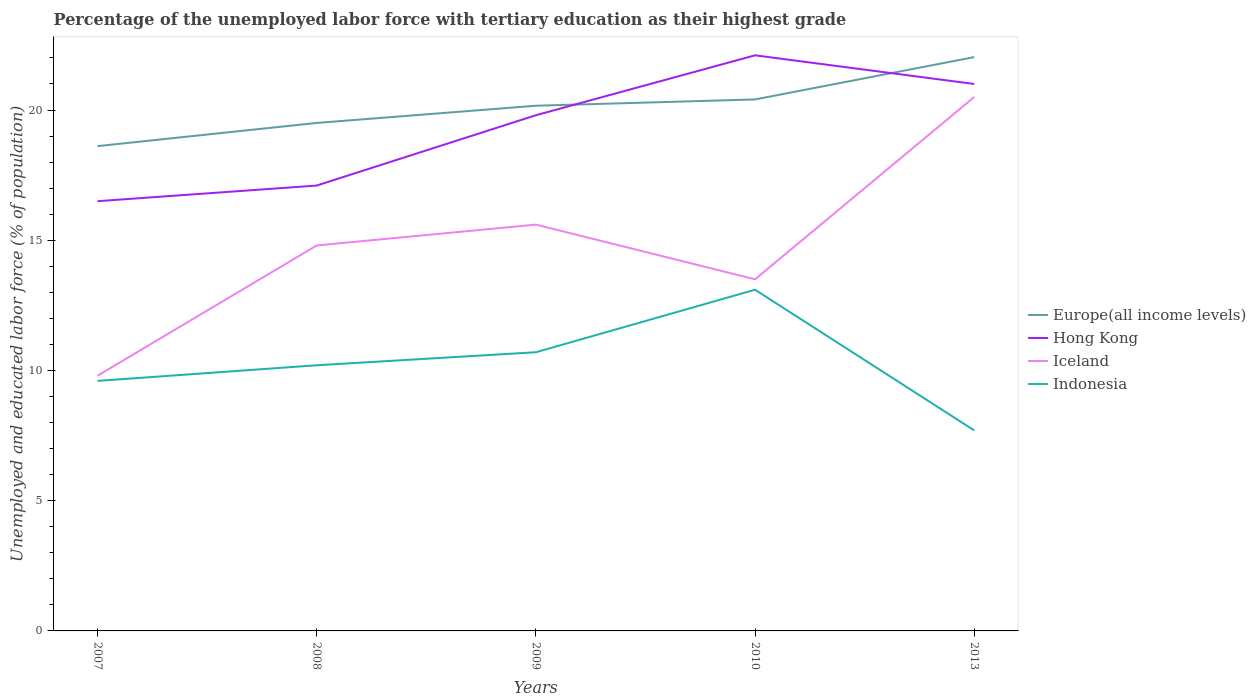How many different coloured lines are there?
Make the answer very short. 4. Does the line corresponding to Hong Kong intersect with the line corresponding to Indonesia?
Your answer should be very brief. No. Across all years, what is the maximum percentage of the unemployed labor force with tertiary education in Iceland?
Your response must be concise. 9.8. What is the total percentage of the unemployed labor force with tertiary education in Iceland in the graph?
Keep it short and to the point. -0.8. What is the difference between the highest and the second highest percentage of the unemployed labor force with tertiary education in Europe(all income levels)?
Make the answer very short. 3.42. What is the difference between the highest and the lowest percentage of the unemployed labor force with tertiary education in Indonesia?
Offer a very short reply. 2. Are the values on the major ticks of Y-axis written in scientific E-notation?
Give a very brief answer. No. Does the graph contain any zero values?
Give a very brief answer. No. Does the graph contain grids?
Provide a succinct answer. No. How many legend labels are there?
Make the answer very short. 4. How are the legend labels stacked?
Offer a terse response. Vertical. What is the title of the graph?
Keep it short and to the point. Percentage of the unemployed labor force with tertiary education as their highest grade. Does "Kyrgyz Republic" appear as one of the legend labels in the graph?
Ensure brevity in your answer.  No. What is the label or title of the Y-axis?
Provide a succinct answer. Unemployed and educated labor force (% of population). What is the Unemployed and educated labor force (% of population) of Europe(all income levels) in 2007?
Offer a terse response. 18.61. What is the Unemployed and educated labor force (% of population) of Iceland in 2007?
Make the answer very short. 9.8. What is the Unemployed and educated labor force (% of population) in Indonesia in 2007?
Provide a succinct answer. 9.6. What is the Unemployed and educated labor force (% of population) in Europe(all income levels) in 2008?
Make the answer very short. 19.5. What is the Unemployed and educated labor force (% of population) of Hong Kong in 2008?
Keep it short and to the point. 17.1. What is the Unemployed and educated labor force (% of population) in Iceland in 2008?
Make the answer very short. 14.8. What is the Unemployed and educated labor force (% of population) of Indonesia in 2008?
Ensure brevity in your answer.  10.2. What is the Unemployed and educated labor force (% of population) of Europe(all income levels) in 2009?
Offer a terse response. 20.16. What is the Unemployed and educated labor force (% of population) of Hong Kong in 2009?
Offer a very short reply. 19.8. What is the Unemployed and educated labor force (% of population) in Iceland in 2009?
Your answer should be very brief. 15.6. What is the Unemployed and educated labor force (% of population) in Indonesia in 2009?
Ensure brevity in your answer.  10.7. What is the Unemployed and educated labor force (% of population) in Europe(all income levels) in 2010?
Your answer should be compact. 20.41. What is the Unemployed and educated labor force (% of population) of Hong Kong in 2010?
Your answer should be very brief. 22.1. What is the Unemployed and educated labor force (% of population) of Indonesia in 2010?
Keep it short and to the point. 13.1. What is the Unemployed and educated labor force (% of population) in Europe(all income levels) in 2013?
Give a very brief answer. 22.03. What is the Unemployed and educated labor force (% of population) of Hong Kong in 2013?
Offer a terse response. 21. What is the Unemployed and educated labor force (% of population) of Indonesia in 2013?
Keep it short and to the point. 7.7. Across all years, what is the maximum Unemployed and educated labor force (% of population) of Europe(all income levels)?
Offer a terse response. 22.03. Across all years, what is the maximum Unemployed and educated labor force (% of population) of Hong Kong?
Your answer should be very brief. 22.1. Across all years, what is the maximum Unemployed and educated labor force (% of population) in Iceland?
Your answer should be very brief. 20.5. Across all years, what is the maximum Unemployed and educated labor force (% of population) in Indonesia?
Ensure brevity in your answer.  13.1. Across all years, what is the minimum Unemployed and educated labor force (% of population) in Europe(all income levels)?
Ensure brevity in your answer.  18.61. Across all years, what is the minimum Unemployed and educated labor force (% of population) in Hong Kong?
Provide a succinct answer. 16.5. Across all years, what is the minimum Unemployed and educated labor force (% of population) of Iceland?
Your answer should be compact. 9.8. Across all years, what is the minimum Unemployed and educated labor force (% of population) in Indonesia?
Offer a very short reply. 7.7. What is the total Unemployed and educated labor force (% of population) of Europe(all income levels) in the graph?
Keep it short and to the point. 100.72. What is the total Unemployed and educated labor force (% of population) in Hong Kong in the graph?
Your response must be concise. 96.5. What is the total Unemployed and educated labor force (% of population) of Iceland in the graph?
Ensure brevity in your answer.  74.2. What is the total Unemployed and educated labor force (% of population) of Indonesia in the graph?
Offer a terse response. 51.3. What is the difference between the Unemployed and educated labor force (% of population) of Europe(all income levels) in 2007 and that in 2008?
Provide a succinct answer. -0.89. What is the difference between the Unemployed and educated labor force (% of population) of Hong Kong in 2007 and that in 2008?
Your response must be concise. -0.6. What is the difference between the Unemployed and educated labor force (% of population) in Iceland in 2007 and that in 2008?
Provide a succinct answer. -5. What is the difference between the Unemployed and educated labor force (% of population) of Europe(all income levels) in 2007 and that in 2009?
Your answer should be very brief. -1.55. What is the difference between the Unemployed and educated labor force (% of population) in Iceland in 2007 and that in 2009?
Keep it short and to the point. -5.8. What is the difference between the Unemployed and educated labor force (% of population) of Indonesia in 2007 and that in 2009?
Offer a very short reply. -1.1. What is the difference between the Unemployed and educated labor force (% of population) in Europe(all income levels) in 2007 and that in 2010?
Your answer should be very brief. -1.79. What is the difference between the Unemployed and educated labor force (% of population) of Hong Kong in 2007 and that in 2010?
Make the answer very short. -5.6. What is the difference between the Unemployed and educated labor force (% of population) in Iceland in 2007 and that in 2010?
Provide a short and direct response. -3.7. What is the difference between the Unemployed and educated labor force (% of population) of Indonesia in 2007 and that in 2010?
Your answer should be very brief. -3.5. What is the difference between the Unemployed and educated labor force (% of population) of Europe(all income levels) in 2007 and that in 2013?
Keep it short and to the point. -3.42. What is the difference between the Unemployed and educated labor force (% of population) of Iceland in 2007 and that in 2013?
Ensure brevity in your answer.  -10.7. What is the difference between the Unemployed and educated labor force (% of population) of Indonesia in 2007 and that in 2013?
Keep it short and to the point. 1.9. What is the difference between the Unemployed and educated labor force (% of population) of Europe(all income levels) in 2008 and that in 2009?
Your response must be concise. -0.66. What is the difference between the Unemployed and educated labor force (% of population) of Hong Kong in 2008 and that in 2009?
Offer a terse response. -2.7. What is the difference between the Unemployed and educated labor force (% of population) in Indonesia in 2008 and that in 2009?
Make the answer very short. -0.5. What is the difference between the Unemployed and educated labor force (% of population) in Europe(all income levels) in 2008 and that in 2010?
Provide a succinct answer. -0.9. What is the difference between the Unemployed and educated labor force (% of population) of Europe(all income levels) in 2008 and that in 2013?
Ensure brevity in your answer.  -2.53. What is the difference between the Unemployed and educated labor force (% of population) of Hong Kong in 2008 and that in 2013?
Provide a succinct answer. -3.9. What is the difference between the Unemployed and educated labor force (% of population) of Europe(all income levels) in 2009 and that in 2010?
Make the answer very short. -0.24. What is the difference between the Unemployed and educated labor force (% of population) of Europe(all income levels) in 2009 and that in 2013?
Your answer should be very brief. -1.87. What is the difference between the Unemployed and educated labor force (% of population) in Indonesia in 2009 and that in 2013?
Keep it short and to the point. 3. What is the difference between the Unemployed and educated labor force (% of population) in Europe(all income levels) in 2010 and that in 2013?
Make the answer very short. -1.62. What is the difference between the Unemployed and educated labor force (% of population) in Iceland in 2010 and that in 2013?
Offer a very short reply. -7. What is the difference between the Unemployed and educated labor force (% of population) of Europe(all income levels) in 2007 and the Unemployed and educated labor force (% of population) of Hong Kong in 2008?
Offer a terse response. 1.51. What is the difference between the Unemployed and educated labor force (% of population) in Europe(all income levels) in 2007 and the Unemployed and educated labor force (% of population) in Iceland in 2008?
Your answer should be compact. 3.81. What is the difference between the Unemployed and educated labor force (% of population) in Europe(all income levels) in 2007 and the Unemployed and educated labor force (% of population) in Indonesia in 2008?
Make the answer very short. 8.41. What is the difference between the Unemployed and educated labor force (% of population) in Iceland in 2007 and the Unemployed and educated labor force (% of population) in Indonesia in 2008?
Your answer should be compact. -0.4. What is the difference between the Unemployed and educated labor force (% of population) in Europe(all income levels) in 2007 and the Unemployed and educated labor force (% of population) in Hong Kong in 2009?
Make the answer very short. -1.19. What is the difference between the Unemployed and educated labor force (% of population) in Europe(all income levels) in 2007 and the Unemployed and educated labor force (% of population) in Iceland in 2009?
Offer a very short reply. 3.01. What is the difference between the Unemployed and educated labor force (% of population) in Europe(all income levels) in 2007 and the Unemployed and educated labor force (% of population) in Indonesia in 2009?
Ensure brevity in your answer.  7.91. What is the difference between the Unemployed and educated labor force (% of population) in Hong Kong in 2007 and the Unemployed and educated labor force (% of population) in Iceland in 2009?
Offer a terse response. 0.9. What is the difference between the Unemployed and educated labor force (% of population) of Hong Kong in 2007 and the Unemployed and educated labor force (% of population) of Indonesia in 2009?
Keep it short and to the point. 5.8. What is the difference between the Unemployed and educated labor force (% of population) of Europe(all income levels) in 2007 and the Unemployed and educated labor force (% of population) of Hong Kong in 2010?
Offer a very short reply. -3.49. What is the difference between the Unemployed and educated labor force (% of population) in Europe(all income levels) in 2007 and the Unemployed and educated labor force (% of population) in Iceland in 2010?
Your response must be concise. 5.11. What is the difference between the Unemployed and educated labor force (% of population) of Europe(all income levels) in 2007 and the Unemployed and educated labor force (% of population) of Indonesia in 2010?
Offer a very short reply. 5.51. What is the difference between the Unemployed and educated labor force (% of population) in Hong Kong in 2007 and the Unemployed and educated labor force (% of population) in Indonesia in 2010?
Keep it short and to the point. 3.4. What is the difference between the Unemployed and educated labor force (% of population) of Iceland in 2007 and the Unemployed and educated labor force (% of population) of Indonesia in 2010?
Ensure brevity in your answer.  -3.3. What is the difference between the Unemployed and educated labor force (% of population) in Europe(all income levels) in 2007 and the Unemployed and educated labor force (% of population) in Hong Kong in 2013?
Your answer should be compact. -2.39. What is the difference between the Unemployed and educated labor force (% of population) of Europe(all income levels) in 2007 and the Unemployed and educated labor force (% of population) of Iceland in 2013?
Make the answer very short. -1.89. What is the difference between the Unemployed and educated labor force (% of population) in Europe(all income levels) in 2007 and the Unemployed and educated labor force (% of population) in Indonesia in 2013?
Offer a very short reply. 10.91. What is the difference between the Unemployed and educated labor force (% of population) in Europe(all income levels) in 2008 and the Unemployed and educated labor force (% of population) in Hong Kong in 2009?
Keep it short and to the point. -0.3. What is the difference between the Unemployed and educated labor force (% of population) of Europe(all income levels) in 2008 and the Unemployed and educated labor force (% of population) of Iceland in 2009?
Your response must be concise. 3.9. What is the difference between the Unemployed and educated labor force (% of population) of Europe(all income levels) in 2008 and the Unemployed and educated labor force (% of population) of Indonesia in 2009?
Offer a terse response. 8.8. What is the difference between the Unemployed and educated labor force (% of population) of Hong Kong in 2008 and the Unemployed and educated labor force (% of population) of Indonesia in 2009?
Offer a terse response. 6.4. What is the difference between the Unemployed and educated labor force (% of population) of Europe(all income levels) in 2008 and the Unemployed and educated labor force (% of population) of Hong Kong in 2010?
Offer a very short reply. -2.6. What is the difference between the Unemployed and educated labor force (% of population) of Europe(all income levels) in 2008 and the Unemployed and educated labor force (% of population) of Iceland in 2010?
Ensure brevity in your answer.  6. What is the difference between the Unemployed and educated labor force (% of population) of Europe(all income levels) in 2008 and the Unemployed and educated labor force (% of population) of Indonesia in 2010?
Your answer should be compact. 6.4. What is the difference between the Unemployed and educated labor force (% of population) in Hong Kong in 2008 and the Unemployed and educated labor force (% of population) in Iceland in 2010?
Provide a succinct answer. 3.6. What is the difference between the Unemployed and educated labor force (% of population) in Hong Kong in 2008 and the Unemployed and educated labor force (% of population) in Indonesia in 2010?
Ensure brevity in your answer.  4. What is the difference between the Unemployed and educated labor force (% of population) in Europe(all income levels) in 2008 and the Unemployed and educated labor force (% of population) in Hong Kong in 2013?
Give a very brief answer. -1.5. What is the difference between the Unemployed and educated labor force (% of population) of Europe(all income levels) in 2008 and the Unemployed and educated labor force (% of population) of Iceland in 2013?
Keep it short and to the point. -1. What is the difference between the Unemployed and educated labor force (% of population) of Europe(all income levels) in 2008 and the Unemployed and educated labor force (% of population) of Indonesia in 2013?
Keep it short and to the point. 11.8. What is the difference between the Unemployed and educated labor force (% of population) in Hong Kong in 2008 and the Unemployed and educated labor force (% of population) in Indonesia in 2013?
Provide a succinct answer. 9.4. What is the difference between the Unemployed and educated labor force (% of population) in Europe(all income levels) in 2009 and the Unemployed and educated labor force (% of population) in Hong Kong in 2010?
Provide a short and direct response. -1.94. What is the difference between the Unemployed and educated labor force (% of population) of Europe(all income levels) in 2009 and the Unemployed and educated labor force (% of population) of Iceland in 2010?
Your response must be concise. 6.66. What is the difference between the Unemployed and educated labor force (% of population) of Europe(all income levels) in 2009 and the Unemployed and educated labor force (% of population) of Indonesia in 2010?
Your answer should be compact. 7.06. What is the difference between the Unemployed and educated labor force (% of population) of Hong Kong in 2009 and the Unemployed and educated labor force (% of population) of Iceland in 2010?
Your response must be concise. 6.3. What is the difference between the Unemployed and educated labor force (% of population) of Europe(all income levels) in 2009 and the Unemployed and educated labor force (% of population) of Hong Kong in 2013?
Provide a short and direct response. -0.84. What is the difference between the Unemployed and educated labor force (% of population) in Europe(all income levels) in 2009 and the Unemployed and educated labor force (% of population) in Iceland in 2013?
Offer a very short reply. -0.34. What is the difference between the Unemployed and educated labor force (% of population) of Europe(all income levels) in 2009 and the Unemployed and educated labor force (% of population) of Indonesia in 2013?
Give a very brief answer. 12.46. What is the difference between the Unemployed and educated labor force (% of population) in Hong Kong in 2009 and the Unemployed and educated labor force (% of population) in Iceland in 2013?
Offer a terse response. -0.7. What is the difference between the Unemployed and educated labor force (% of population) in Hong Kong in 2009 and the Unemployed and educated labor force (% of population) in Indonesia in 2013?
Ensure brevity in your answer.  12.1. What is the difference between the Unemployed and educated labor force (% of population) in Europe(all income levels) in 2010 and the Unemployed and educated labor force (% of population) in Hong Kong in 2013?
Provide a short and direct response. -0.59. What is the difference between the Unemployed and educated labor force (% of population) in Europe(all income levels) in 2010 and the Unemployed and educated labor force (% of population) in Iceland in 2013?
Your response must be concise. -0.09. What is the difference between the Unemployed and educated labor force (% of population) in Europe(all income levels) in 2010 and the Unemployed and educated labor force (% of population) in Indonesia in 2013?
Ensure brevity in your answer.  12.71. What is the difference between the Unemployed and educated labor force (% of population) in Hong Kong in 2010 and the Unemployed and educated labor force (% of population) in Indonesia in 2013?
Give a very brief answer. 14.4. What is the average Unemployed and educated labor force (% of population) in Europe(all income levels) per year?
Your answer should be compact. 20.14. What is the average Unemployed and educated labor force (% of population) of Hong Kong per year?
Your answer should be compact. 19.3. What is the average Unemployed and educated labor force (% of population) in Iceland per year?
Provide a short and direct response. 14.84. What is the average Unemployed and educated labor force (% of population) of Indonesia per year?
Make the answer very short. 10.26. In the year 2007, what is the difference between the Unemployed and educated labor force (% of population) in Europe(all income levels) and Unemployed and educated labor force (% of population) in Hong Kong?
Give a very brief answer. 2.11. In the year 2007, what is the difference between the Unemployed and educated labor force (% of population) in Europe(all income levels) and Unemployed and educated labor force (% of population) in Iceland?
Give a very brief answer. 8.81. In the year 2007, what is the difference between the Unemployed and educated labor force (% of population) of Europe(all income levels) and Unemployed and educated labor force (% of population) of Indonesia?
Keep it short and to the point. 9.01. In the year 2007, what is the difference between the Unemployed and educated labor force (% of population) of Hong Kong and Unemployed and educated labor force (% of population) of Iceland?
Your answer should be compact. 6.7. In the year 2007, what is the difference between the Unemployed and educated labor force (% of population) in Hong Kong and Unemployed and educated labor force (% of population) in Indonesia?
Ensure brevity in your answer.  6.9. In the year 2008, what is the difference between the Unemployed and educated labor force (% of population) of Europe(all income levels) and Unemployed and educated labor force (% of population) of Hong Kong?
Offer a very short reply. 2.4. In the year 2008, what is the difference between the Unemployed and educated labor force (% of population) of Europe(all income levels) and Unemployed and educated labor force (% of population) of Iceland?
Make the answer very short. 4.7. In the year 2008, what is the difference between the Unemployed and educated labor force (% of population) of Europe(all income levels) and Unemployed and educated labor force (% of population) of Indonesia?
Ensure brevity in your answer.  9.3. In the year 2009, what is the difference between the Unemployed and educated labor force (% of population) of Europe(all income levels) and Unemployed and educated labor force (% of population) of Hong Kong?
Give a very brief answer. 0.36. In the year 2009, what is the difference between the Unemployed and educated labor force (% of population) in Europe(all income levels) and Unemployed and educated labor force (% of population) in Iceland?
Ensure brevity in your answer.  4.56. In the year 2009, what is the difference between the Unemployed and educated labor force (% of population) in Europe(all income levels) and Unemployed and educated labor force (% of population) in Indonesia?
Your answer should be very brief. 9.46. In the year 2009, what is the difference between the Unemployed and educated labor force (% of population) in Hong Kong and Unemployed and educated labor force (% of population) in Iceland?
Ensure brevity in your answer.  4.2. In the year 2009, what is the difference between the Unemployed and educated labor force (% of population) of Hong Kong and Unemployed and educated labor force (% of population) of Indonesia?
Your response must be concise. 9.1. In the year 2009, what is the difference between the Unemployed and educated labor force (% of population) of Iceland and Unemployed and educated labor force (% of population) of Indonesia?
Offer a very short reply. 4.9. In the year 2010, what is the difference between the Unemployed and educated labor force (% of population) in Europe(all income levels) and Unemployed and educated labor force (% of population) in Hong Kong?
Keep it short and to the point. -1.69. In the year 2010, what is the difference between the Unemployed and educated labor force (% of population) of Europe(all income levels) and Unemployed and educated labor force (% of population) of Iceland?
Make the answer very short. 6.91. In the year 2010, what is the difference between the Unemployed and educated labor force (% of population) in Europe(all income levels) and Unemployed and educated labor force (% of population) in Indonesia?
Keep it short and to the point. 7.31. In the year 2010, what is the difference between the Unemployed and educated labor force (% of population) in Hong Kong and Unemployed and educated labor force (% of population) in Iceland?
Give a very brief answer. 8.6. In the year 2010, what is the difference between the Unemployed and educated labor force (% of population) of Iceland and Unemployed and educated labor force (% of population) of Indonesia?
Offer a very short reply. 0.4. In the year 2013, what is the difference between the Unemployed and educated labor force (% of population) in Europe(all income levels) and Unemployed and educated labor force (% of population) in Hong Kong?
Your response must be concise. 1.03. In the year 2013, what is the difference between the Unemployed and educated labor force (% of population) in Europe(all income levels) and Unemployed and educated labor force (% of population) in Iceland?
Your answer should be very brief. 1.53. In the year 2013, what is the difference between the Unemployed and educated labor force (% of population) in Europe(all income levels) and Unemployed and educated labor force (% of population) in Indonesia?
Offer a terse response. 14.33. In the year 2013, what is the difference between the Unemployed and educated labor force (% of population) in Hong Kong and Unemployed and educated labor force (% of population) in Iceland?
Provide a succinct answer. 0.5. In the year 2013, what is the difference between the Unemployed and educated labor force (% of population) of Hong Kong and Unemployed and educated labor force (% of population) of Indonesia?
Offer a terse response. 13.3. What is the ratio of the Unemployed and educated labor force (% of population) of Europe(all income levels) in 2007 to that in 2008?
Your answer should be compact. 0.95. What is the ratio of the Unemployed and educated labor force (% of population) of Hong Kong in 2007 to that in 2008?
Provide a succinct answer. 0.96. What is the ratio of the Unemployed and educated labor force (% of population) in Iceland in 2007 to that in 2008?
Keep it short and to the point. 0.66. What is the ratio of the Unemployed and educated labor force (% of population) in Europe(all income levels) in 2007 to that in 2009?
Keep it short and to the point. 0.92. What is the ratio of the Unemployed and educated labor force (% of population) in Hong Kong in 2007 to that in 2009?
Provide a succinct answer. 0.83. What is the ratio of the Unemployed and educated labor force (% of population) of Iceland in 2007 to that in 2009?
Your response must be concise. 0.63. What is the ratio of the Unemployed and educated labor force (% of population) in Indonesia in 2007 to that in 2009?
Keep it short and to the point. 0.9. What is the ratio of the Unemployed and educated labor force (% of population) in Europe(all income levels) in 2007 to that in 2010?
Keep it short and to the point. 0.91. What is the ratio of the Unemployed and educated labor force (% of population) of Hong Kong in 2007 to that in 2010?
Offer a terse response. 0.75. What is the ratio of the Unemployed and educated labor force (% of population) in Iceland in 2007 to that in 2010?
Keep it short and to the point. 0.73. What is the ratio of the Unemployed and educated labor force (% of population) in Indonesia in 2007 to that in 2010?
Offer a terse response. 0.73. What is the ratio of the Unemployed and educated labor force (% of population) in Europe(all income levels) in 2007 to that in 2013?
Provide a short and direct response. 0.84. What is the ratio of the Unemployed and educated labor force (% of population) of Hong Kong in 2007 to that in 2013?
Make the answer very short. 0.79. What is the ratio of the Unemployed and educated labor force (% of population) in Iceland in 2007 to that in 2013?
Make the answer very short. 0.48. What is the ratio of the Unemployed and educated labor force (% of population) of Indonesia in 2007 to that in 2013?
Your response must be concise. 1.25. What is the ratio of the Unemployed and educated labor force (% of population) in Europe(all income levels) in 2008 to that in 2009?
Ensure brevity in your answer.  0.97. What is the ratio of the Unemployed and educated labor force (% of population) of Hong Kong in 2008 to that in 2009?
Your response must be concise. 0.86. What is the ratio of the Unemployed and educated labor force (% of population) in Iceland in 2008 to that in 2009?
Give a very brief answer. 0.95. What is the ratio of the Unemployed and educated labor force (% of population) of Indonesia in 2008 to that in 2009?
Your response must be concise. 0.95. What is the ratio of the Unemployed and educated labor force (% of population) of Europe(all income levels) in 2008 to that in 2010?
Offer a terse response. 0.96. What is the ratio of the Unemployed and educated labor force (% of population) in Hong Kong in 2008 to that in 2010?
Provide a succinct answer. 0.77. What is the ratio of the Unemployed and educated labor force (% of population) of Iceland in 2008 to that in 2010?
Give a very brief answer. 1.1. What is the ratio of the Unemployed and educated labor force (% of population) in Indonesia in 2008 to that in 2010?
Make the answer very short. 0.78. What is the ratio of the Unemployed and educated labor force (% of population) of Europe(all income levels) in 2008 to that in 2013?
Offer a very short reply. 0.89. What is the ratio of the Unemployed and educated labor force (% of population) in Hong Kong in 2008 to that in 2013?
Ensure brevity in your answer.  0.81. What is the ratio of the Unemployed and educated labor force (% of population) of Iceland in 2008 to that in 2013?
Offer a terse response. 0.72. What is the ratio of the Unemployed and educated labor force (% of population) of Indonesia in 2008 to that in 2013?
Make the answer very short. 1.32. What is the ratio of the Unemployed and educated labor force (% of population) of Europe(all income levels) in 2009 to that in 2010?
Your answer should be compact. 0.99. What is the ratio of the Unemployed and educated labor force (% of population) of Hong Kong in 2009 to that in 2010?
Provide a succinct answer. 0.9. What is the ratio of the Unemployed and educated labor force (% of population) of Iceland in 2009 to that in 2010?
Keep it short and to the point. 1.16. What is the ratio of the Unemployed and educated labor force (% of population) of Indonesia in 2009 to that in 2010?
Offer a very short reply. 0.82. What is the ratio of the Unemployed and educated labor force (% of population) in Europe(all income levels) in 2009 to that in 2013?
Give a very brief answer. 0.92. What is the ratio of the Unemployed and educated labor force (% of population) in Hong Kong in 2009 to that in 2013?
Ensure brevity in your answer.  0.94. What is the ratio of the Unemployed and educated labor force (% of population) in Iceland in 2009 to that in 2013?
Your answer should be very brief. 0.76. What is the ratio of the Unemployed and educated labor force (% of population) in Indonesia in 2009 to that in 2013?
Provide a short and direct response. 1.39. What is the ratio of the Unemployed and educated labor force (% of population) in Europe(all income levels) in 2010 to that in 2013?
Your answer should be compact. 0.93. What is the ratio of the Unemployed and educated labor force (% of population) in Hong Kong in 2010 to that in 2013?
Your response must be concise. 1.05. What is the ratio of the Unemployed and educated labor force (% of population) of Iceland in 2010 to that in 2013?
Your answer should be very brief. 0.66. What is the ratio of the Unemployed and educated labor force (% of population) in Indonesia in 2010 to that in 2013?
Make the answer very short. 1.7. What is the difference between the highest and the second highest Unemployed and educated labor force (% of population) of Europe(all income levels)?
Give a very brief answer. 1.62. What is the difference between the highest and the lowest Unemployed and educated labor force (% of population) in Europe(all income levels)?
Provide a short and direct response. 3.42. 